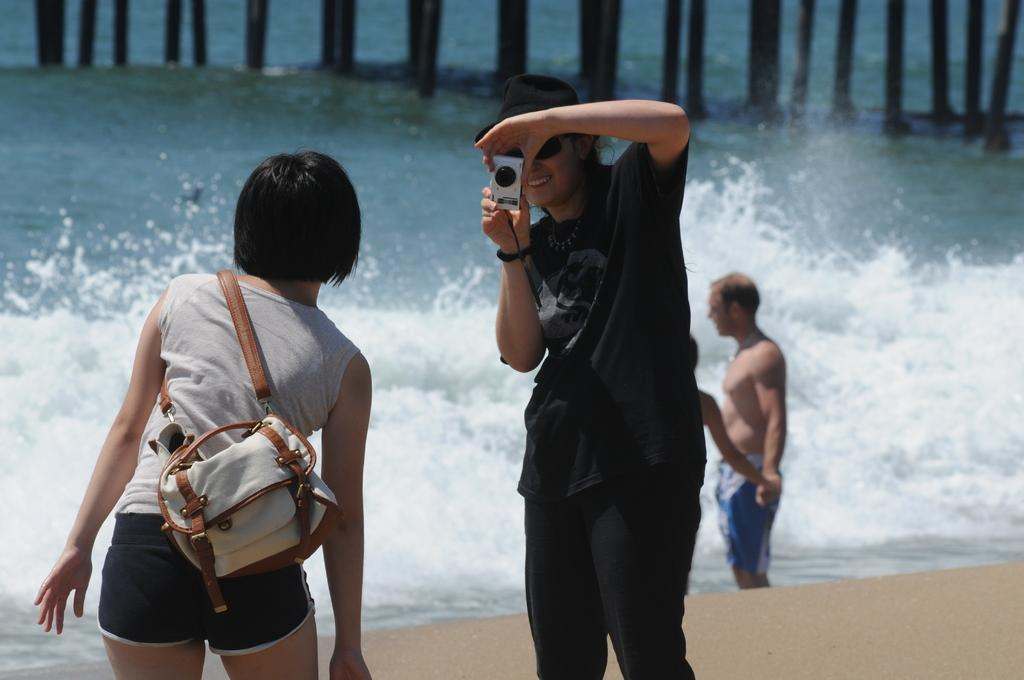Who is the main subject in the image? There is a woman in the image. What is the woman wearing on her head? The woman is wearing a black hat. What is the woman holding in her hands? The woman is holding a camera. What is the woman doing with the camera? The woman is taking a picture. Who else is present in the image? There are persons standing in the image. What can be seen in the background of the image? The persons are standing in front of a sea. What type of religious authority is depicted in the image? There is no religious authority present in the image; it features a woman taking a picture of persons standing in front of a sea. Is there a bed visible in the image? No, there is no bed present in the image. 